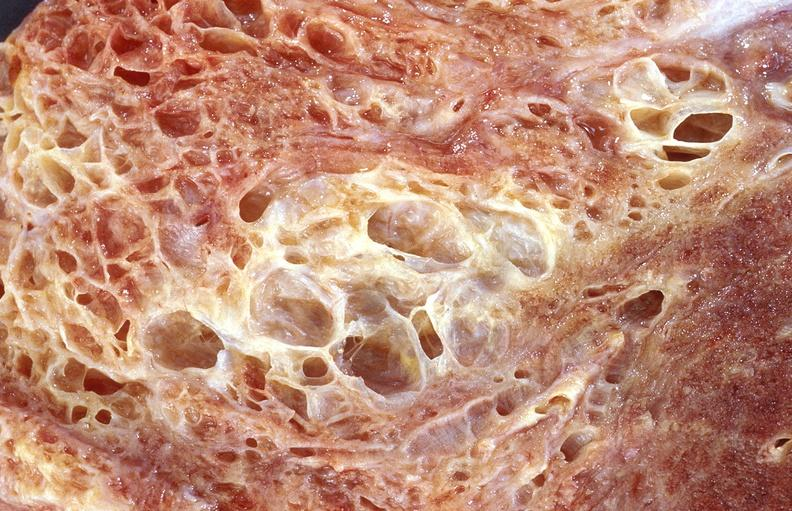where is this?
Answer the question using a single word or phrase. Lung 